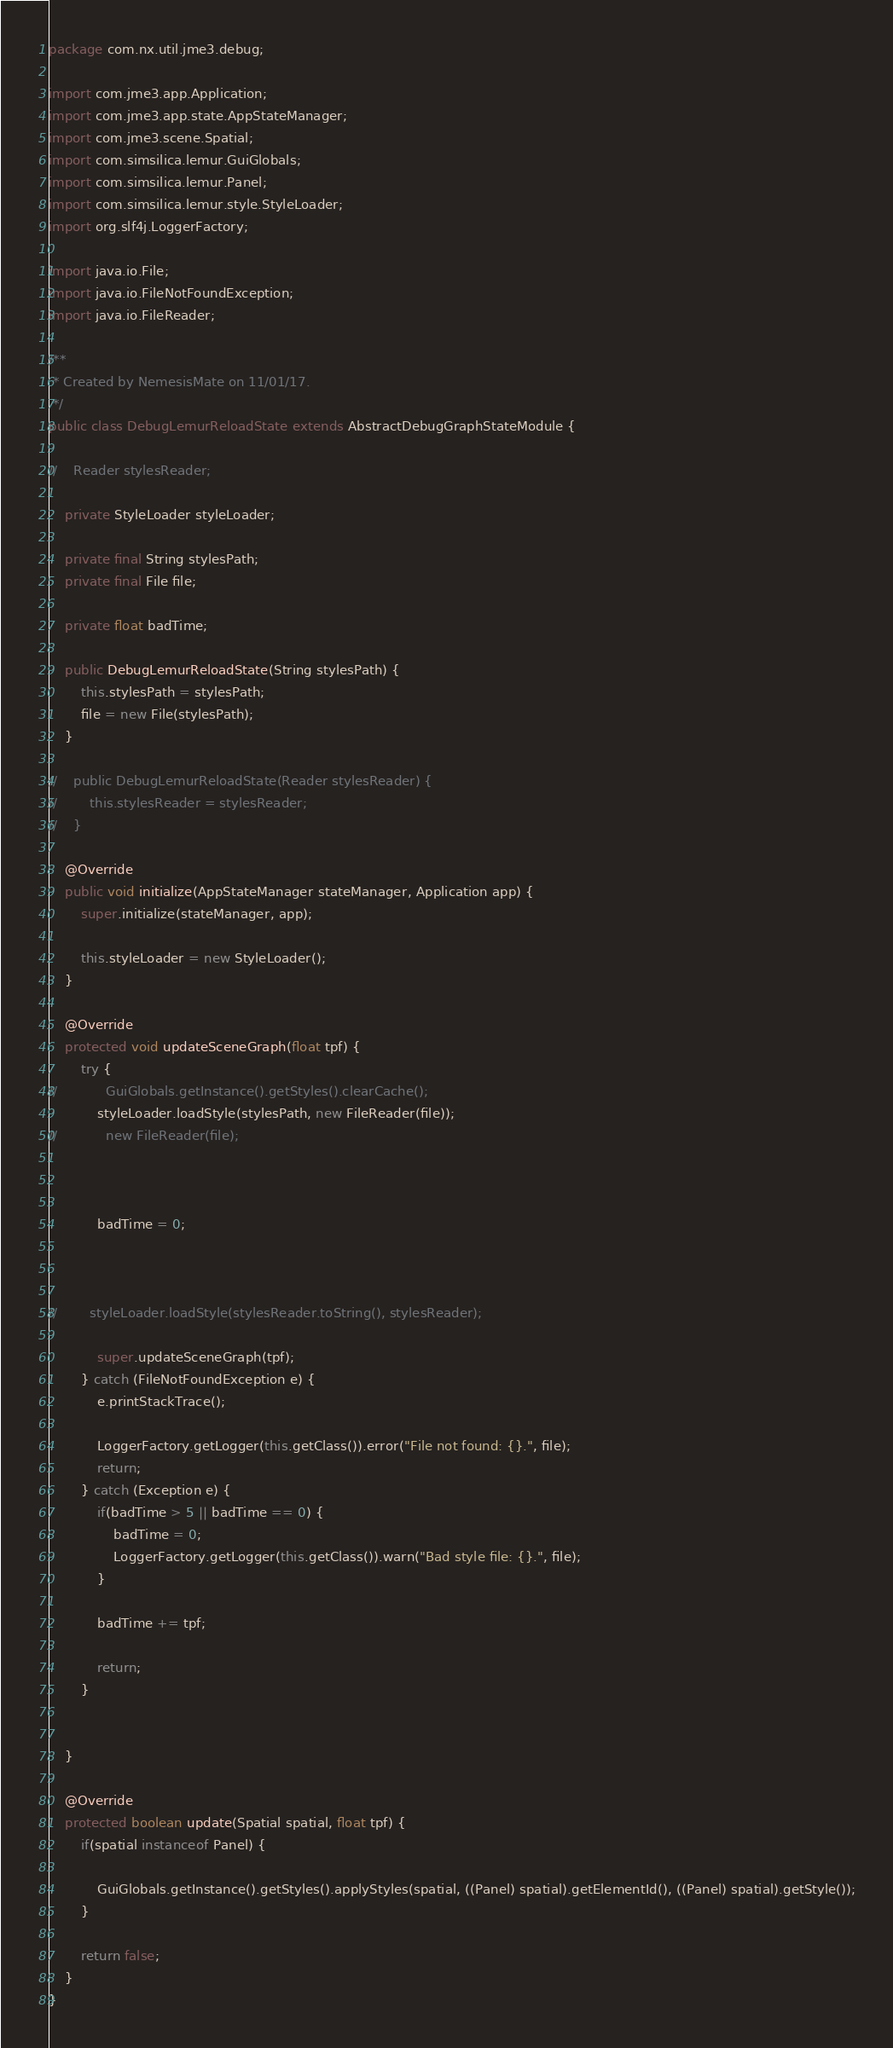Convert code to text. <code><loc_0><loc_0><loc_500><loc_500><_Java_>package com.nx.util.jme3.debug;

import com.jme3.app.Application;
import com.jme3.app.state.AppStateManager;
import com.jme3.scene.Spatial;
import com.simsilica.lemur.GuiGlobals;
import com.simsilica.lemur.Panel;
import com.simsilica.lemur.style.StyleLoader;
import org.slf4j.LoggerFactory;

import java.io.File;
import java.io.FileNotFoundException;
import java.io.FileReader;

/**
 * Created by NemesisMate on 11/01/17.
 */
public class DebugLemurReloadState extends AbstractDebugGraphStateModule {

//    Reader stylesReader;

    private StyleLoader styleLoader;

    private final String stylesPath;
    private final File file;

    private float badTime;

    public DebugLemurReloadState(String stylesPath) {
        this.stylesPath = stylesPath;
        file = new File(stylesPath);
    }

//    public DebugLemurReloadState(Reader stylesReader) {
//        this.stylesReader = stylesReader;
//    }

    @Override
    public void initialize(AppStateManager stateManager, Application app) {
        super.initialize(stateManager, app);

        this.styleLoader = new StyleLoader();
    }

    @Override
    protected void updateSceneGraph(float tpf) {
        try {
//            GuiGlobals.getInstance().getStyles().clearCache();
            styleLoader.loadStyle(stylesPath, new FileReader(file));
//            new FileReader(file);



            badTime = 0;



//        styleLoader.loadStyle(stylesReader.toString(), stylesReader);

            super.updateSceneGraph(tpf);
        } catch (FileNotFoundException e) {
            e.printStackTrace();

            LoggerFactory.getLogger(this.getClass()).error("File not found: {}.", file);
            return;
        } catch (Exception e) {
            if(badTime > 5 || badTime == 0) {
                badTime = 0;
                LoggerFactory.getLogger(this.getClass()).warn("Bad style file: {}.", file);
            }

            badTime += tpf;

            return;
        }


    }

    @Override
    protected boolean update(Spatial spatial, float tpf) {
        if(spatial instanceof Panel) {

            GuiGlobals.getInstance().getStyles().applyStyles(spatial, ((Panel) spatial).getElementId(), ((Panel) spatial).getStyle());
        }

        return false;
    }
}
</code> 